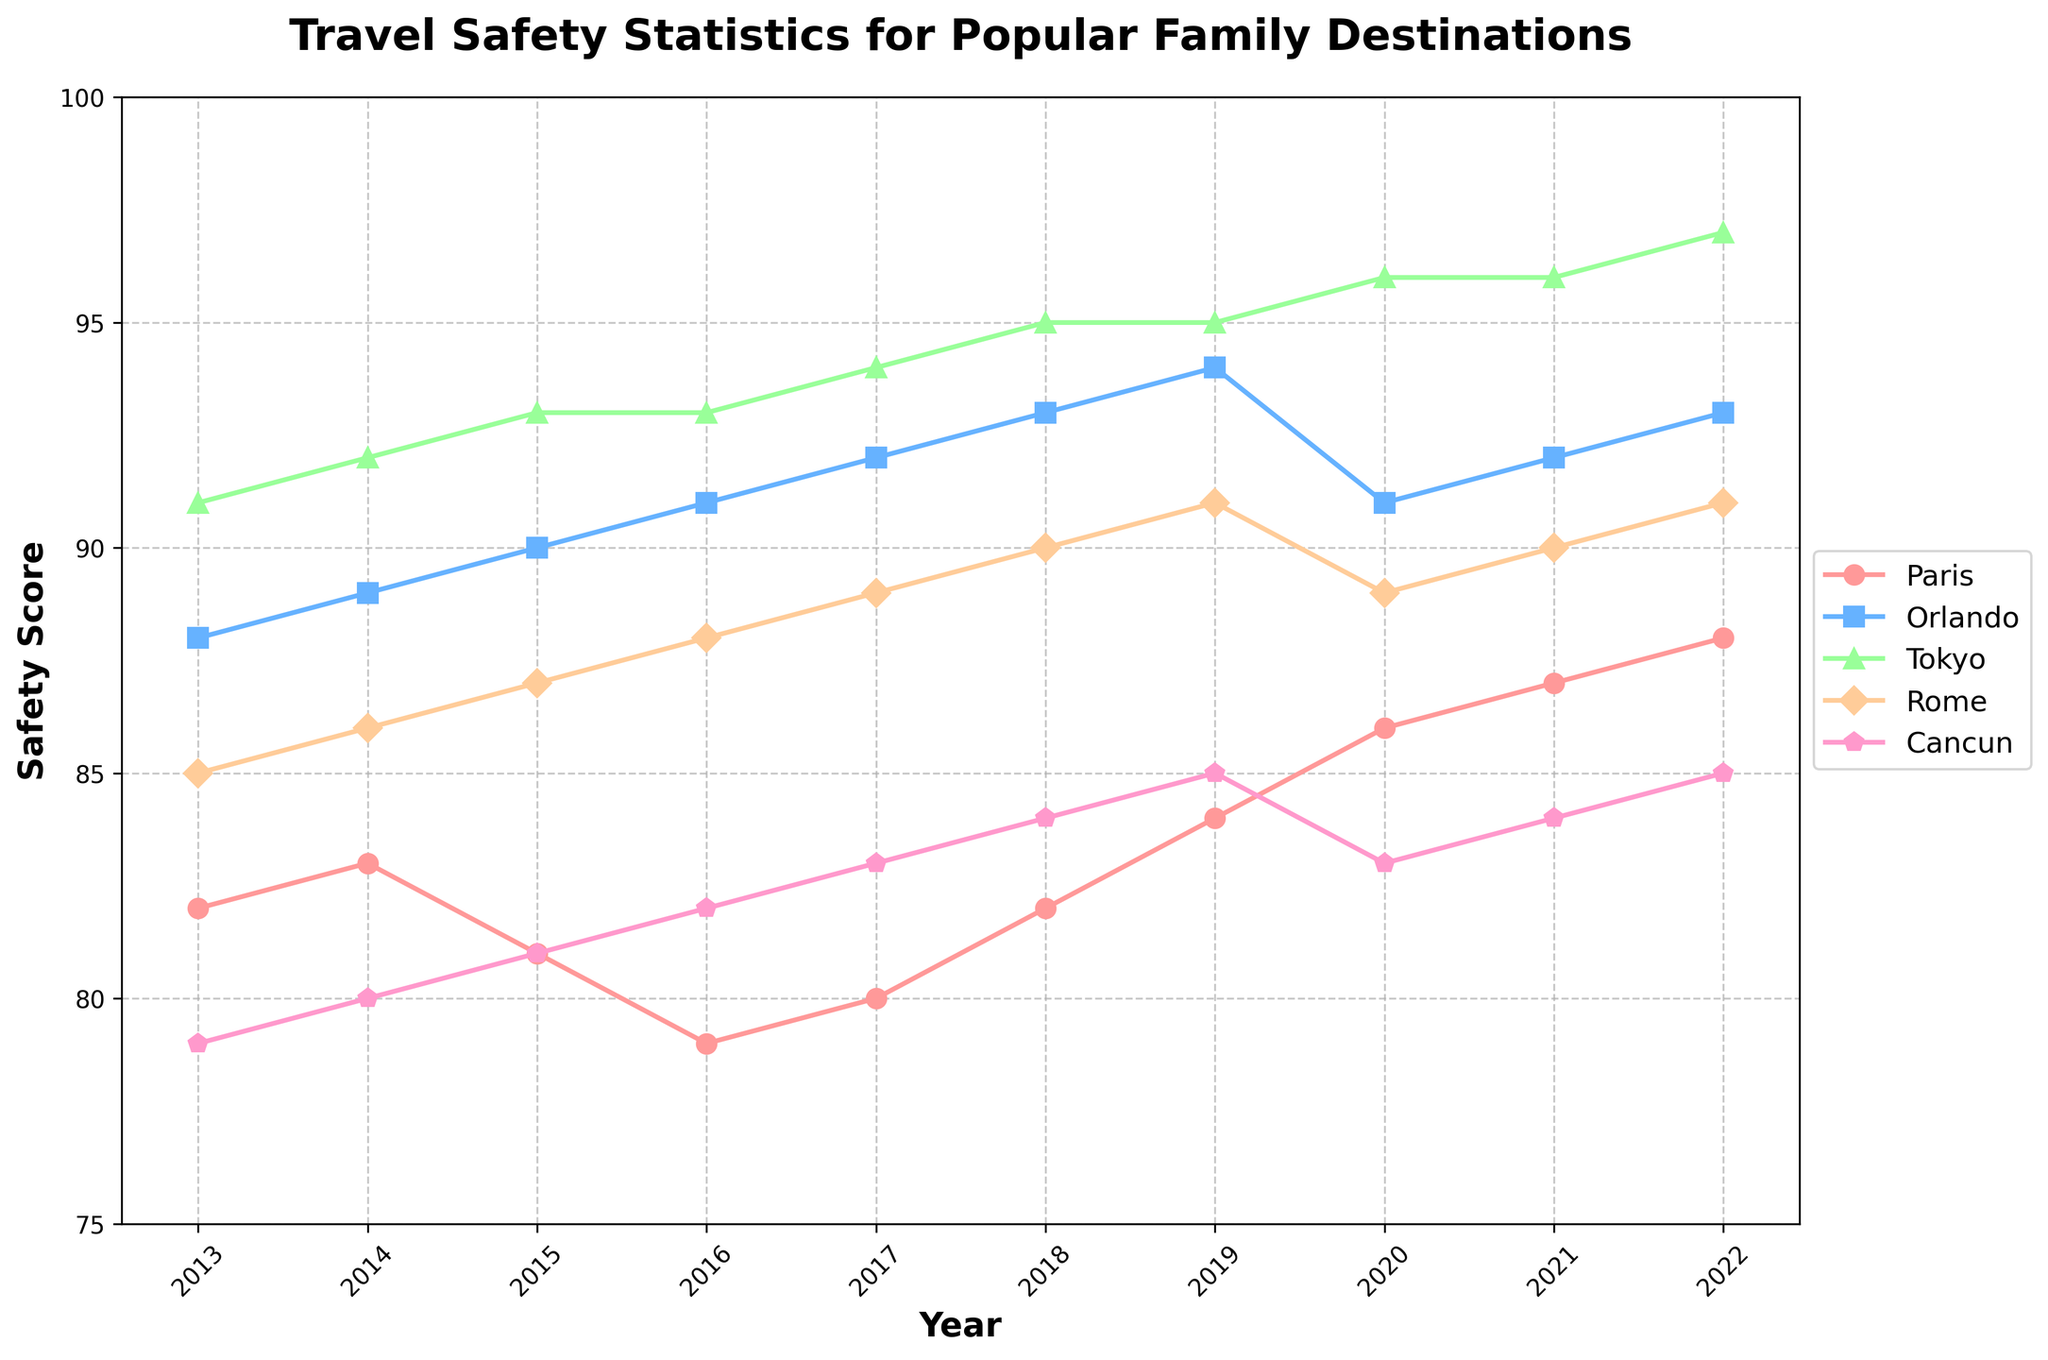Which destination had the lowest safety score in 2013? To find the lowest safety score in 2013, look at the scores for all destinations in that year: Paris: 82, Orlando: 88, Tokyo: 91, Rome: 85, Cancun: 79. Cancun has the lowest score of 79.
Answer: Cancun How did the safety score of Tokyo change from 2013 to 2022? To determine the change in safety score for Tokyo, subtract the 2013 score from the 2022 score: 97 - 91 = 6. Tokyo's safety score increased by 6.
Answer: Increased by 6 Which destination has the steadiest increase in safety score over the decade? To determine this, look at the trend of the lines. Orlando's line increases steadily each year without any dips.
Answer: Orlando What is the average safety score for Paris across the decade? Add up all the yearly scores for Paris and divide by the total number of years: (82 + 83 + 81 + 79 + 80 + 82 + 84 + 86 + 87 + 88) / 10 = 83.2
Answer: 83.2 Which year did Rome have the highest safety score? Look at the Rome line and identify its peak value, which is 91 in 2022.
Answer: 2022 Compare the overall trend in safety scores for Cancun and Tokyo. Cancun's scores increase almost every year but are lower compared to Tokyo, which consistently rises and reaches 97 in 2022. Cancun's highest is 85, much lower than Tokyo's.
Answer: Tokyo's trend is higher What is the difference in safety scores between Orlando and Rome in 2020? Subtract Rome's safety score in 2020 from Orlando's: 91 - 89 = 2.
Answer: 2 Which destination consistently had higher safety scores than Paris? Compare the Paris line to the others each year. Orlando and Tokyo consistently had higher scores.
Answer: Orlando and Tokyo Which destination showed the greatest improvement from 2013 to 2022? Calculate the score differences for all destinations: Paris: 6, Orlando: 5, Tokyo: 6, Rome: 6, Cancun: 6. Several destinations improved by 6 but Tokyo ended with the highest score.
Answer: Tokyo Was there any year when all destinations had increasing safety scores compared to the previous year? Check each year and observe increments for each destination. Only 2015 shows an increase across all destinations from the previous year (2014).
Answer: 2015 